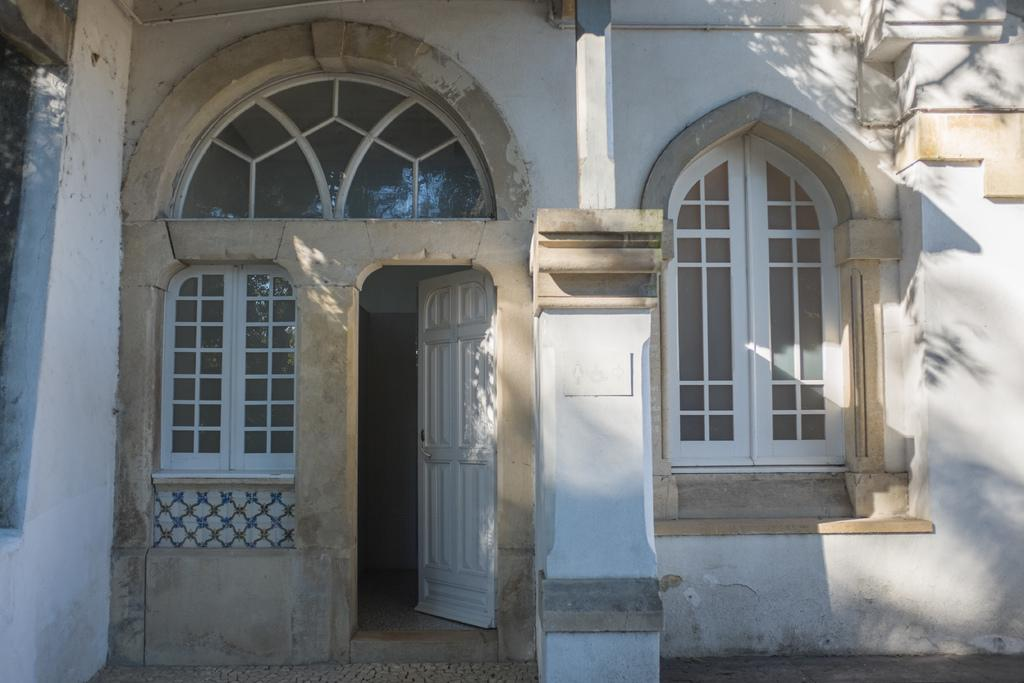What is the main structure in the image? There is a house in the center of the image. What can be used to enter or exit the house? There is a door in the image. How can natural light enter the house? There is a window in the image. How does the house swim in the image? The house does not swim in the image; it is a stationary structure. 